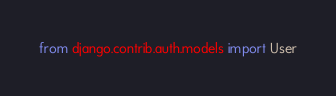Convert code to text. <code><loc_0><loc_0><loc_500><loc_500><_Python_>from django.contrib.auth.models import User
</code> 